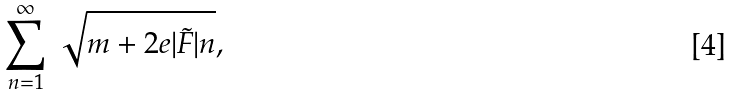Convert formula to latex. <formula><loc_0><loc_0><loc_500><loc_500>\sum _ { n = 1 } ^ { \infty } \, \sqrt { m + 2 e | { \tilde { F } } | n } ,</formula> 